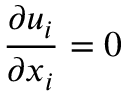<formula> <loc_0><loc_0><loc_500><loc_500>{ \frac { \partial u _ { i } } { \partial x _ { i } } } = 0</formula> 